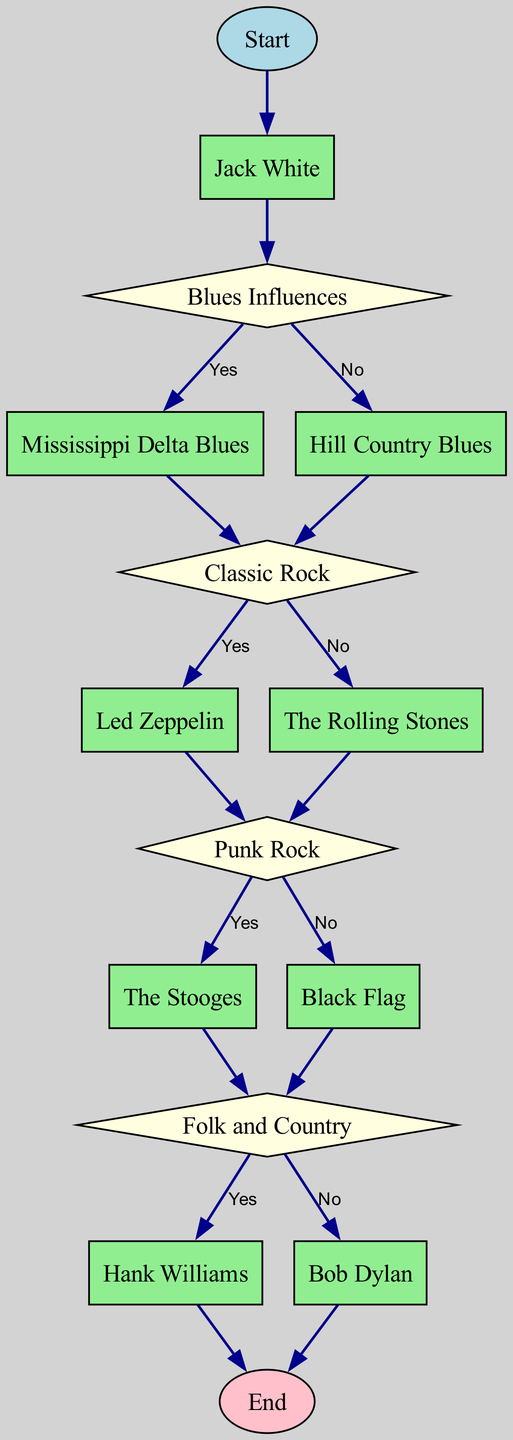What is the initial node in the diagram? The initial node in the diagram is "Start," which marks the beginning of the flowchart. This is typically the first node in most flowcharts, representing where the process initiates.
Answer: Start How many decision nodes are present in the diagram? By examining the flowchart, we can count the decision nodes, which are "Blues Influences," "Classic Rock," "Punk Rock," and "Folk and Country." There are a total of four decision nodes.
Answer: 4 What follows after "Mississippi Delta Blues"? Following "Mississippi Delta Blues," the flowchart leads to the "Classic Rock" node directly, indicating that the influence continues in that direction.
Answer: Classic Rock Which node leads to "Hank Williams"? The node leading to "Hank Williams" is "Folk and Country." From there, it provides a decision pathway that connects to "Hank Williams" depending on the affirmative response to the question posed at that decision node.
Answer: Folk and Country If the answer to "Punk Rock" is "Yes," which node comes next? If the answer to "Punk Rock" is "Yes," the flowchart goes to the node "The Stooges." This shows a continued influence from punk rock towards the specific artist.
Answer: The Stooges Which musical genre comes immediately after "Classic Rock" if the answer is "No"? If the answer to "Classic Rock" is "No," the flowchart shows that it leads to "The Rolling Stones," indicating a different pathway rooted in classic rock influences.
Answer: The Rolling Stones Describe the relationship between "Black Flag" and "Folk and Country." In the flowchart, "Black Flag" connects to "Folk and Country," showing that after considering "No" to punk influences, the music influences move towards folk and country.
Answer: Direct connection How many musical influences does "Jack White" trace through the diagram? By following the connections from "Jack White" through various genres and artists, we see that his influences trace through five distinct musical influences until reaching the end. These are represented by distinct pathways in the diagram.
Answer: 5 What are the last two nodes before reaching the "End"? The last two nodes before reaching the "End" are "Hank Williams" and "Bob Dylan." Depending on which decision is taken, either can lead to the end of the influence mapping.
Answer: Hank Williams and Bob Dylan 